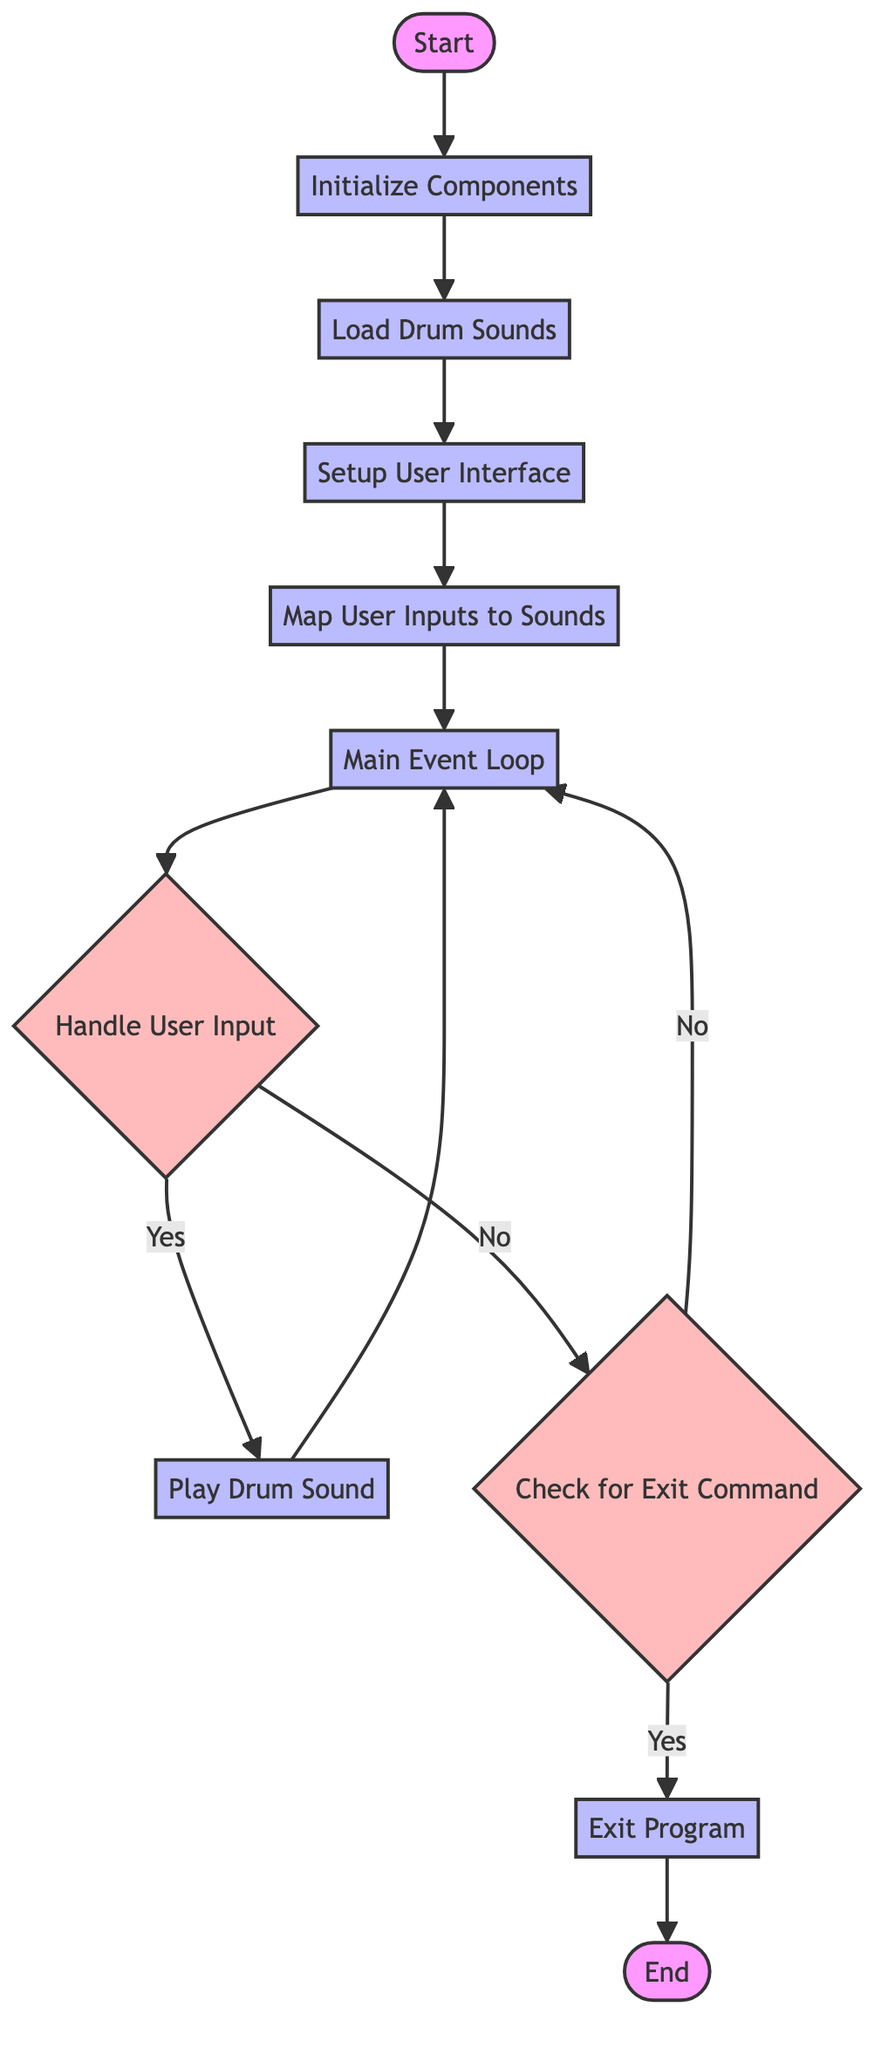What is the first process in the flowchart? The flowchart starts with the 'Initialize Components' process, which is the first step after the 'Start' node.
Answer: Initialize Components How many decision nodes are in the diagram? There are three decision nodes: 'Handle User Input', 'Check for Exit Command', and their corresponding branches.
Answer: 3 What comes after 'Load Drum Sounds'? After 'Load Drum Sounds', the next step is 'Setup User Interface', which follows directly from it in the process flow.
Answer: Setup User Interface What happens if the user input does not match mapped keys? If the user input does not match, the flow goes to 'Check for Exit Command', indicating that there's a check to see if the user wants to exit the program.
Answer: Check for Exit Command Which process leads directly to the 'End' node? The 'Exit Program' process leads directly to the 'End' node, which indicates the program will terminate after this step.
Answer: Exit Program If the user input matches, what process is executed? If the user input matches, it goes to the 'Play Drum Sound' process, which corresponds to the user's action triggering a drum sound.
Answer: Play Drum Sound What is the last action taken before reaching the 'End'? The last action taken before reaching the 'End' is 'Exit Program', which occurs after confirming the exit command from the user.
Answer: Exit Program Which component is responsible for mapping keyboard keys or mouse clicks? The component responsible for mapping inputs is 'Map User Inputs to Sounds', which is essential for associating user actions with drum sounds.
Answer: Map User Inputs to Sounds What does the 'Main Event Loop' do in the flowchart? The 'Main Event Loop' runs continuously, listening for user inputs and executing the associated actions based on those inputs, forming the core of the program's interactivity.
Answer: Main Event Loop 